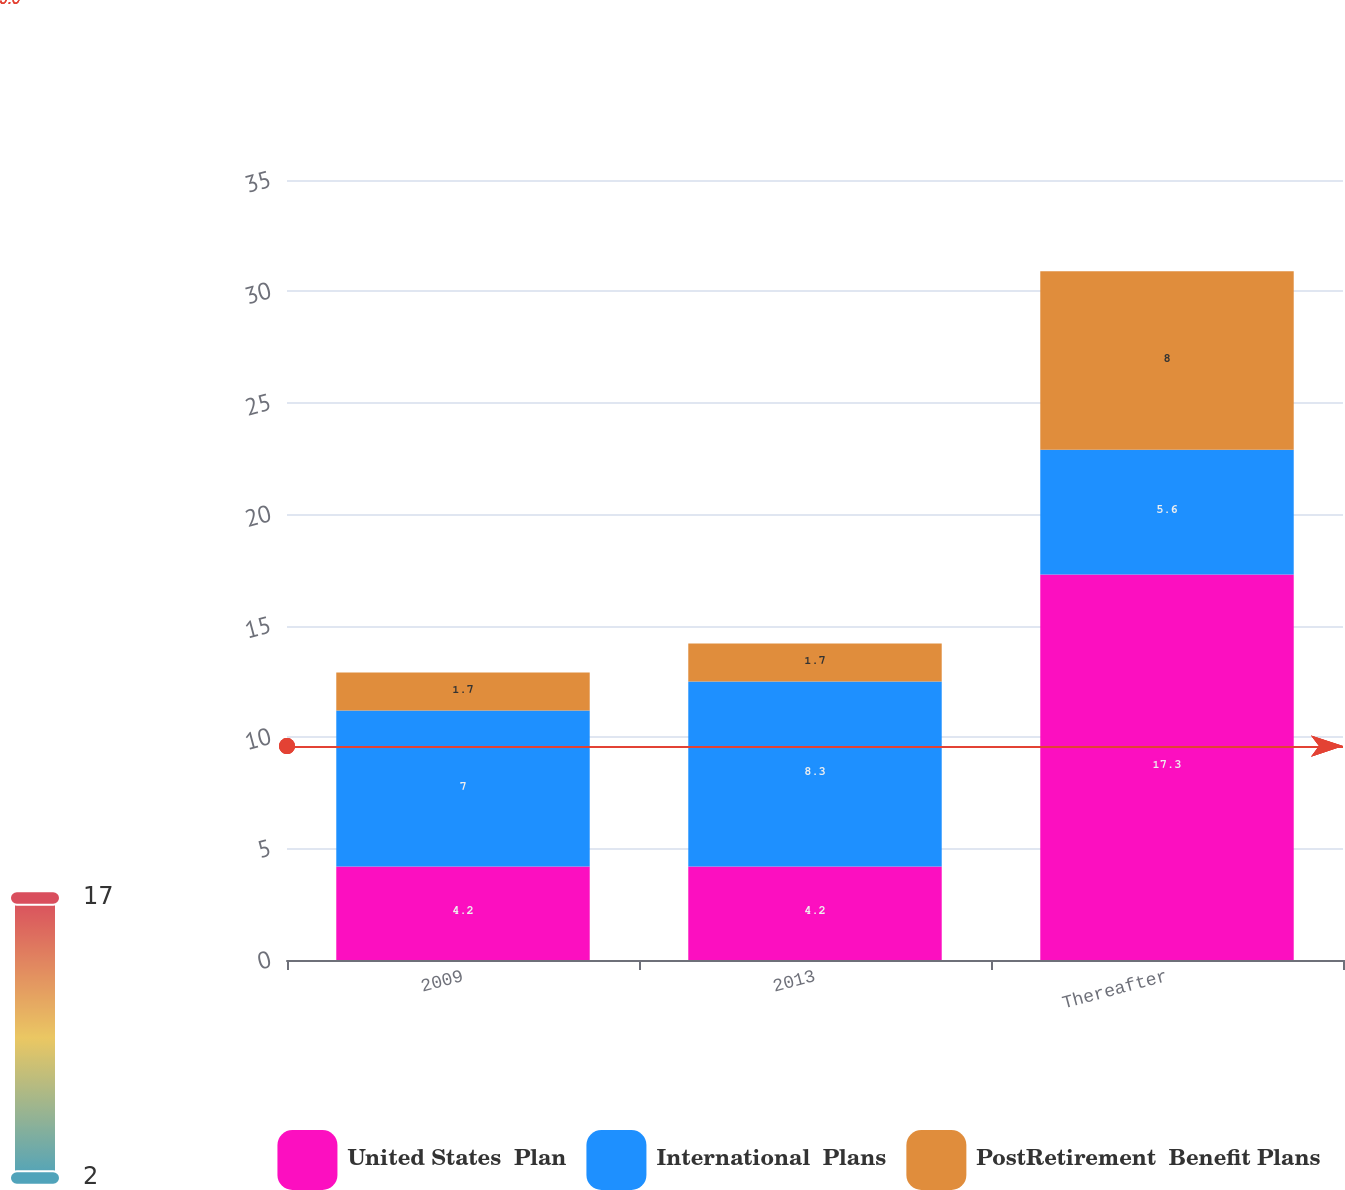Convert chart to OTSL. <chart><loc_0><loc_0><loc_500><loc_500><stacked_bar_chart><ecel><fcel>2009<fcel>2013<fcel>Thereafter<nl><fcel>United States  Plan<fcel>4.2<fcel>4.2<fcel>17.3<nl><fcel>International  Plans<fcel>7<fcel>8.3<fcel>5.6<nl><fcel>PostRetirement  Benefit Plans<fcel>1.7<fcel>1.7<fcel>8<nl></chart> 